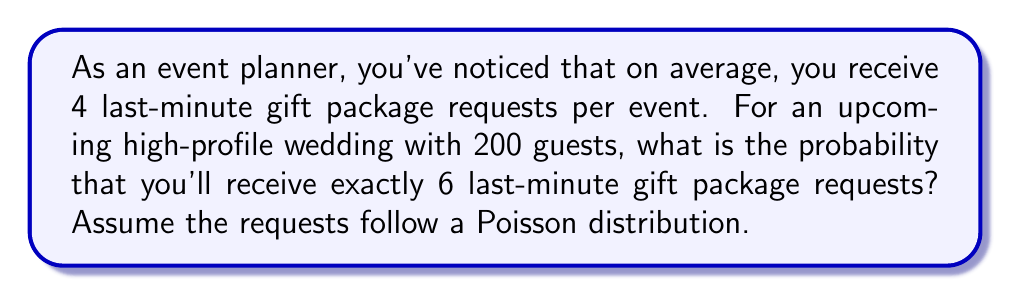Show me your answer to this math problem. To solve this problem, we'll use the Poisson distribution formula:

$$P(X = k) = \frac{e^{-\lambda} \lambda^k}{k!}$$

Where:
- $\lambda$ is the average rate of occurrence
- $k$ is the number of occurrences we're interested in
- $e$ is Euler's number (approximately 2.71828)

Given:
- $\lambda = 4$ (average of 4 last-minute requests per event)
- $k = 6$ (we're interested in exactly 6 requests)

Let's substitute these values into the formula:

$$P(X = 6) = \frac{e^{-4} 4^6}{6!}$$

Now, let's calculate step by step:

1) First, calculate $e^{-4}$:
   $e^{-4} \approx 0.0183$

2) Calculate $4^6$:
   $4^6 = 4096$

3) Calculate $6!$:
   $6! = 6 \times 5 \times 4 \times 3 \times 2 \times 1 = 720$

4) Now, put it all together:

   $$P(X = 6) = \frac{0.0183 \times 4096}{720} \approx 0.1041$$

5) Convert to a percentage:
   $0.1041 \times 100\% \approx 10.41\%$

Therefore, the probability of receiving exactly 6 last-minute gift package requests for this event is approximately 10.41%.
Answer: The probability of receiving exactly 6 last-minute gift package requests is approximately 10.41%. 